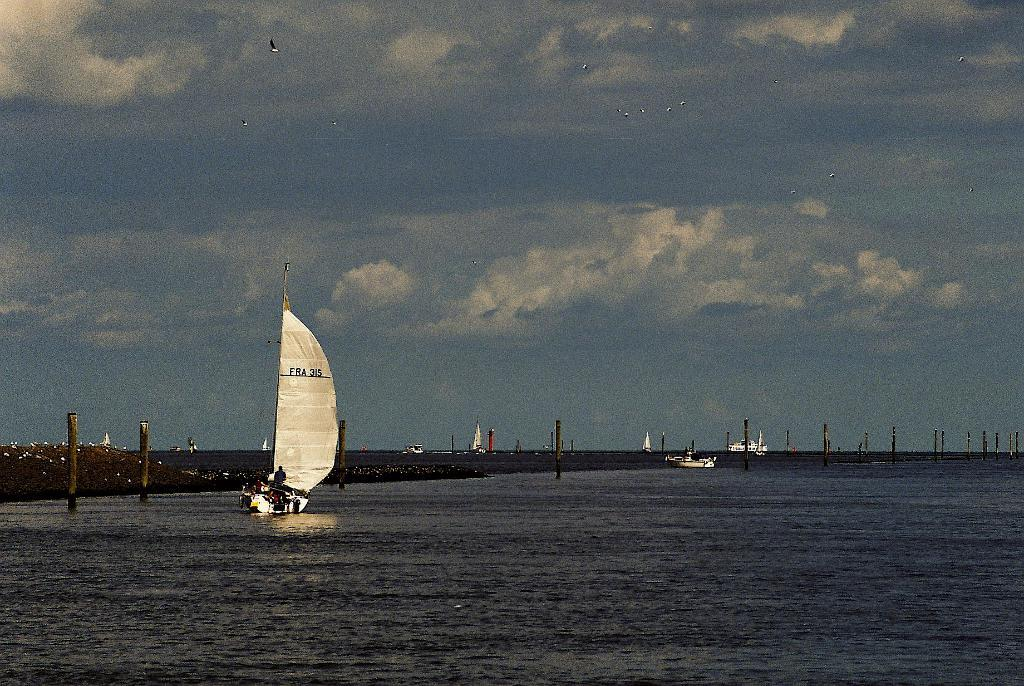What is on the water in the image? There are boats on the water in the image. What else can be seen in the image besides the boats? There are poles visible in the image, as well as birds in the air. What is visible in the background of the image? There are clouds and the sky visible in the background of the image. How does the army interact with the boundary in the image? There is no army or boundary present in the image. Can you touch the birds in the image? The image is a photograph or digital representation, so it is not possible to physically touch the birds in the image. 